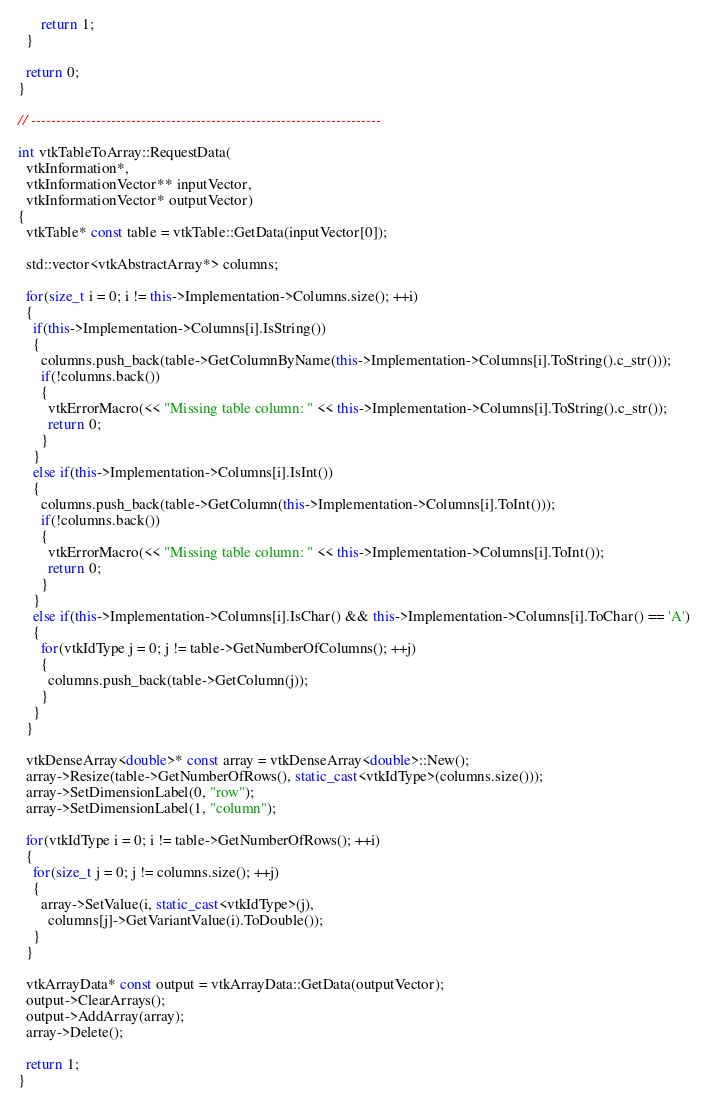Convert code to text. <code><loc_0><loc_0><loc_500><loc_500><_C++_>      return 1;
  }

  return 0;
}

// ----------------------------------------------------------------------

int vtkTableToArray::RequestData(
  vtkInformation*,
  vtkInformationVector** inputVector,
  vtkInformationVector* outputVector)
{
  vtkTable* const table = vtkTable::GetData(inputVector[0]);

  std::vector<vtkAbstractArray*> columns;

  for(size_t i = 0; i != this->Implementation->Columns.size(); ++i)
  {
    if(this->Implementation->Columns[i].IsString())
    {
      columns.push_back(table->GetColumnByName(this->Implementation->Columns[i].ToString().c_str()));
      if(!columns.back())
      {
        vtkErrorMacro(<< "Missing table column: " << this->Implementation->Columns[i].ToString().c_str());
        return 0;
      }
    }
    else if(this->Implementation->Columns[i].IsInt())
    {
      columns.push_back(table->GetColumn(this->Implementation->Columns[i].ToInt()));
      if(!columns.back())
      {
        vtkErrorMacro(<< "Missing table column: " << this->Implementation->Columns[i].ToInt());
        return 0;
      }
    }
    else if(this->Implementation->Columns[i].IsChar() && this->Implementation->Columns[i].ToChar() == 'A')
    {
      for(vtkIdType j = 0; j != table->GetNumberOfColumns(); ++j)
      {
        columns.push_back(table->GetColumn(j));
      }
    }
  }

  vtkDenseArray<double>* const array = vtkDenseArray<double>::New();
  array->Resize(table->GetNumberOfRows(), static_cast<vtkIdType>(columns.size()));
  array->SetDimensionLabel(0, "row");
  array->SetDimensionLabel(1, "column");

  for(vtkIdType i = 0; i != table->GetNumberOfRows(); ++i)
  {
    for(size_t j = 0; j != columns.size(); ++j)
    {
      array->SetValue(i, static_cast<vtkIdType>(j),
        columns[j]->GetVariantValue(i).ToDouble());
    }
  }

  vtkArrayData* const output = vtkArrayData::GetData(outputVector);
  output->ClearArrays();
  output->AddArray(array);
  array->Delete();

  return 1;
}

</code> 